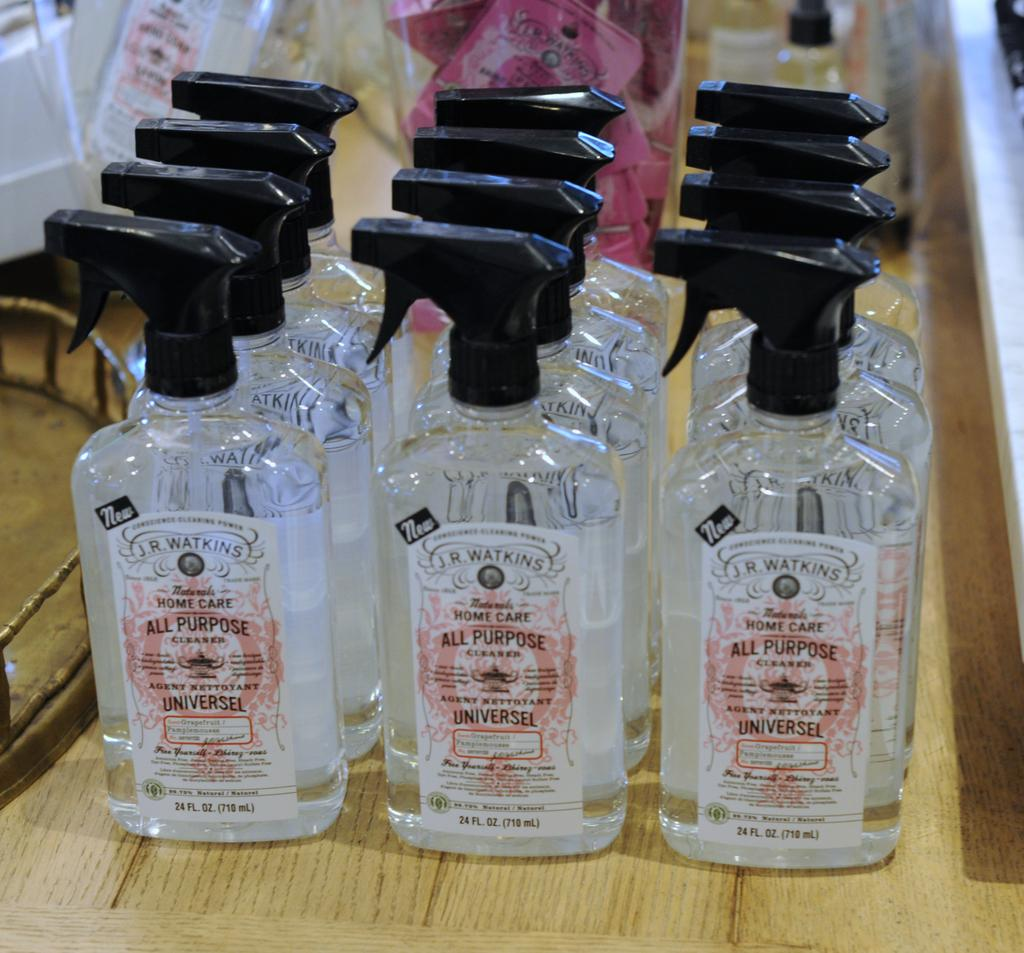<image>
Relay a brief, clear account of the picture shown. clear spray bottles that have labels that say 'all purpose' on them 